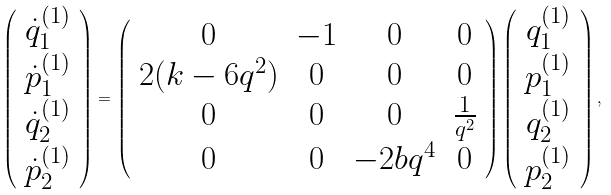<formula> <loc_0><loc_0><loc_500><loc_500>\left ( \begin{array} { c } \dot { q } _ { 1 } ^ { ( 1 ) } \\ \dot { p } _ { 1 } ^ { ( 1 ) } \\ \dot { q } _ { 2 } ^ { ( 1 ) } \\ \dot { p } _ { 2 } ^ { ( 1 ) } \end{array} \right ) = \left ( \begin{array} { c c c c } 0 & - 1 & 0 & 0 \\ 2 ( k - 6 q ^ { 2 } ) & 0 & 0 & 0 \\ 0 & 0 & 0 & \frac { 1 } { q ^ { 2 } } \\ 0 & 0 & - 2 b q ^ { 4 } & 0 \end{array} \right ) \left ( \begin{array} { c } q _ { 1 } ^ { ( 1 ) } \\ p _ { 1 } ^ { ( 1 ) } \\ q _ { 2 } ^ { ( 1 ) } \\ p _ { 2 } ^ { ( 1 ) } \end{array} \right ) ,</formula> 